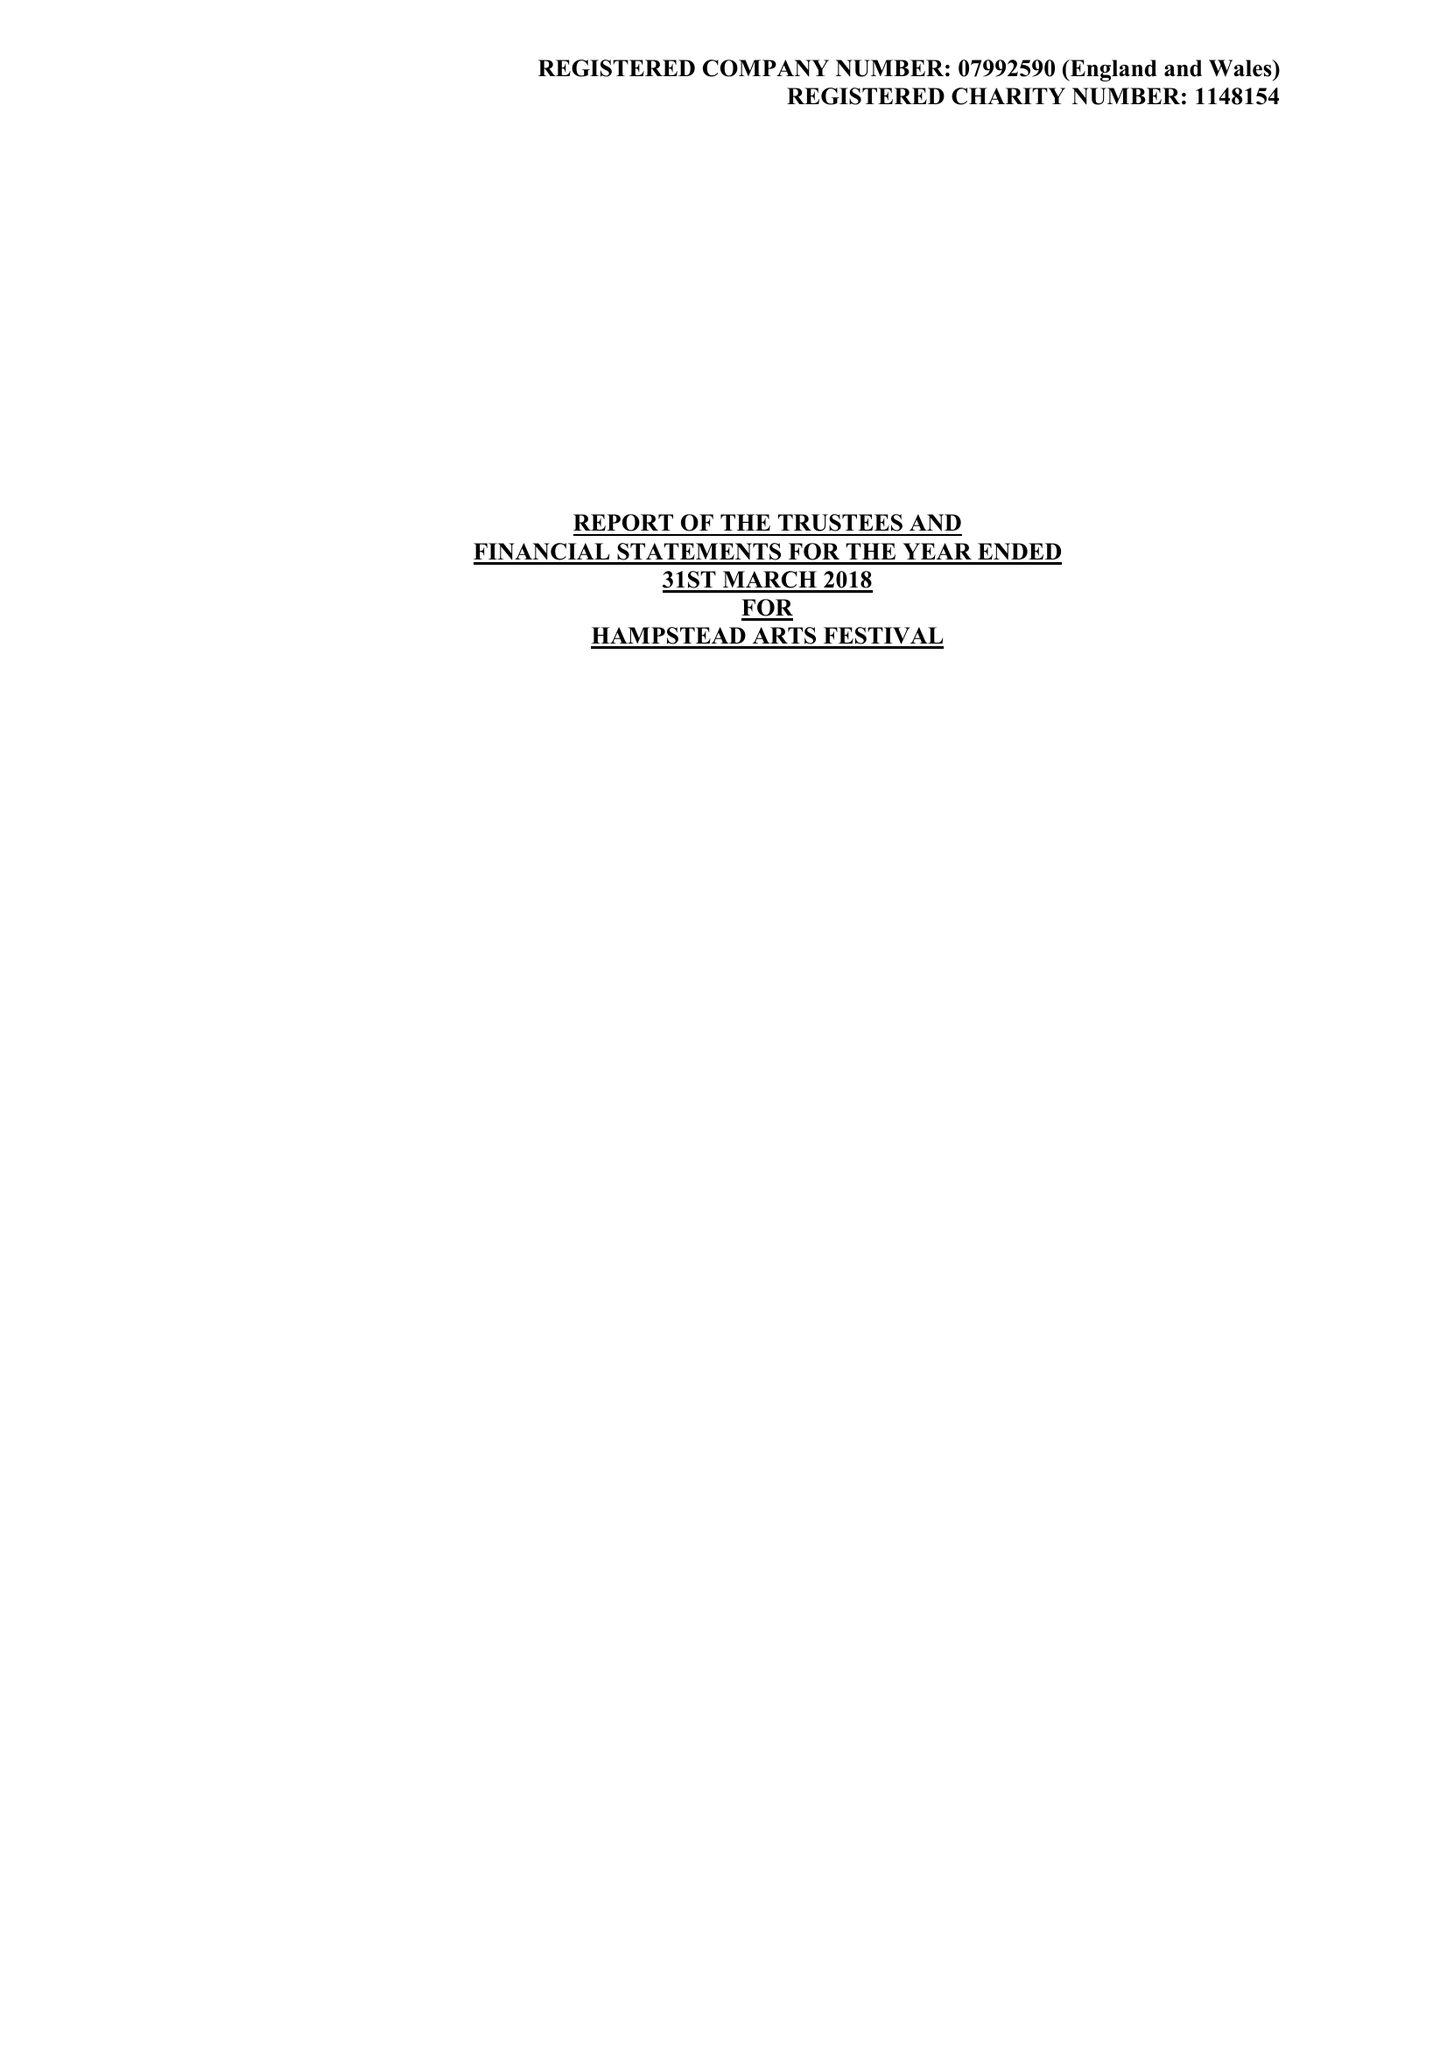What is the value for the spending_annually_in_british_pounds?
Answer the question using a single word or phrase. 37255.00 